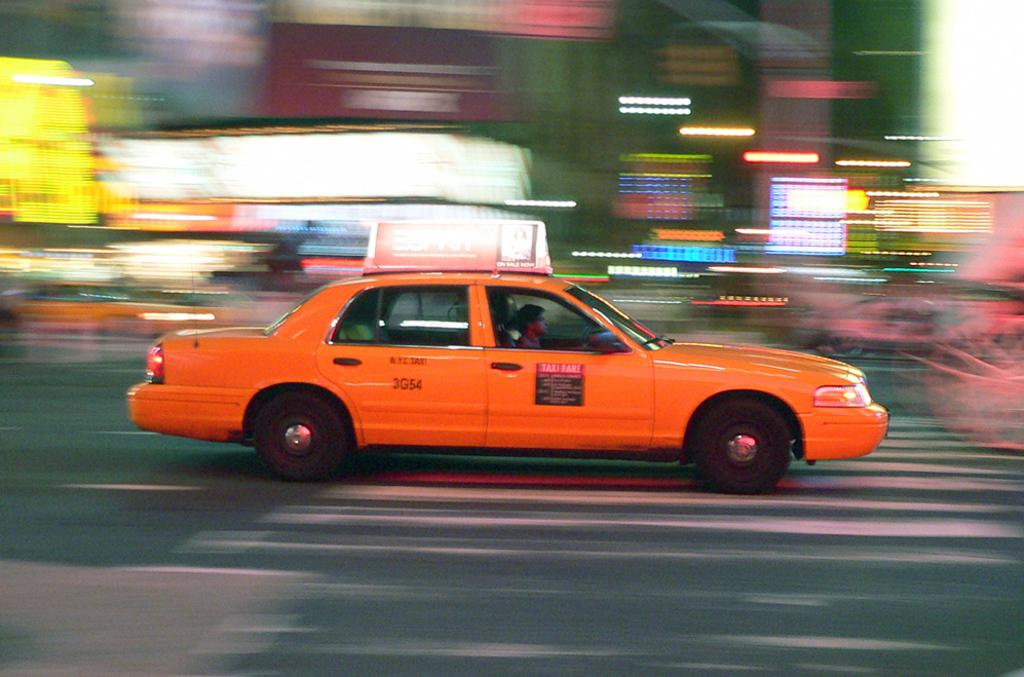<image>
Create a compact narrative representing the image presented. An orange car has the numbers 3G54 on it as it drives on the street. 